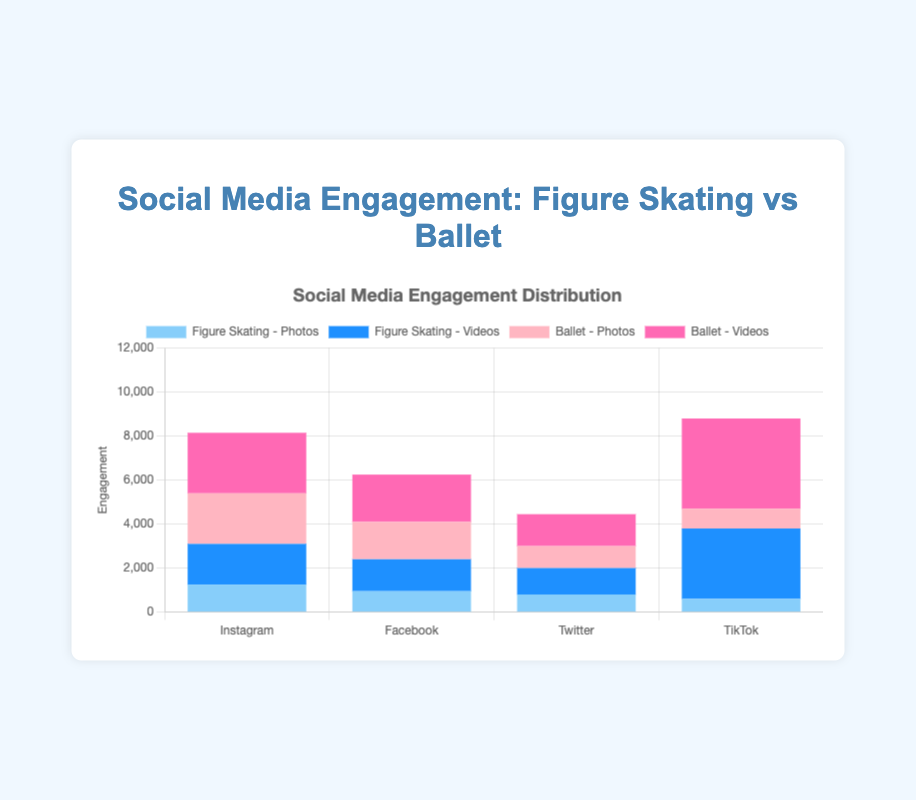Which platform has the highest overall engagement for ballet content? The platform with the highest overall engagement for ballet content can be found by summing the engagement values for both Ballet - Photos and Ballet - Videos for each platform. For Instagram, it's 2300 + 2750 = 5050. For Facebook, it's 1700 + 2150 = 3850. For Twitter, it's 1000 + 1450 = 2450. For TikTok, it's 900 + 4100 = 5000. TikTok has the highest overall engagement for ballet content.
Answer: TikTok Which type of post has the lowest engagement on Twitter across both figure skating and ballet? The engagement values for Twitter are 800 for Figure Skating - Photos, 1200 for Figure Skating - Videos, 1000 for Ballet - Photos, and 1450 for Ballet - Videos. The lowest engagement value among these is 800 for Figure Skating - Photos.
Answer: Figure Skating - Photos How much more engagement do figure skating videos receive on TikTok compared to Facebook? Engagement for Figure Skating - Videos on TikTok is 3200. On Facebook, it's 1450. The difference is 3200 - 1450 = 1750.
Answer: 1750 For Instagram, what is the combined engagement for all figure skating content? The engagement values for Figure Skating on Instagram are 1250 for Photos and 1850 for Videos. The combined engagement is 1250 + 1850 = 3100.
Answer: 3100 Which platform has the greatest difference in engagement between ballet videos and ballet photos? First, calculate the difference for each platform. Instagram: 2750 - 2300 = 450. Facebook: 2150 - 1700 = 450. Twitter: 1450 - 1000 = 450. TikTok: 4100 - 900 = 3200. The greatest difference is on TikTok with 3200.
Answer: TikTok On which platform do figure skating photos perform better in terms of engagement than ballet photos? Compare the engagement values for Figure Skating - Photos and Ballet - Photos on each platform. Instagram: 1250 vs 2300 (ballet performs better). Facebook: 950 vs 1700 (ballet performs better). Twitter: 800 vs 1000 (ballet performs better). TikTok: 600 vs 900 (ballet performs better). None of the platforms have figure skating photos performing better than ballet photos.
Answer: None What is the average engagement for all figure skating posts on Facebook? The engagement values for Figure Skating on Facebook are 950 for Photos and 1450 for Videos. The average engagement is (950 + 1450) / 2 = 2400 / 2 = 1200.
Answer: 1200 Which type of ballet post gets the highest engagement on all platforms combined? Sum the engagement for Ballet - Photos and Ballet - Videos across all platforms. Photos: 2300 (IG) + 1700 (FB) + 1000 (TW) + 900 (TikTok) = 5900. Videos: 2750 (IG) + 2150 (FB) + 1450 (TW) + 4100 (TikTok) = 10450. Ballet - Videos have the highest combined engagement.
Answer: Ballet - Videos 